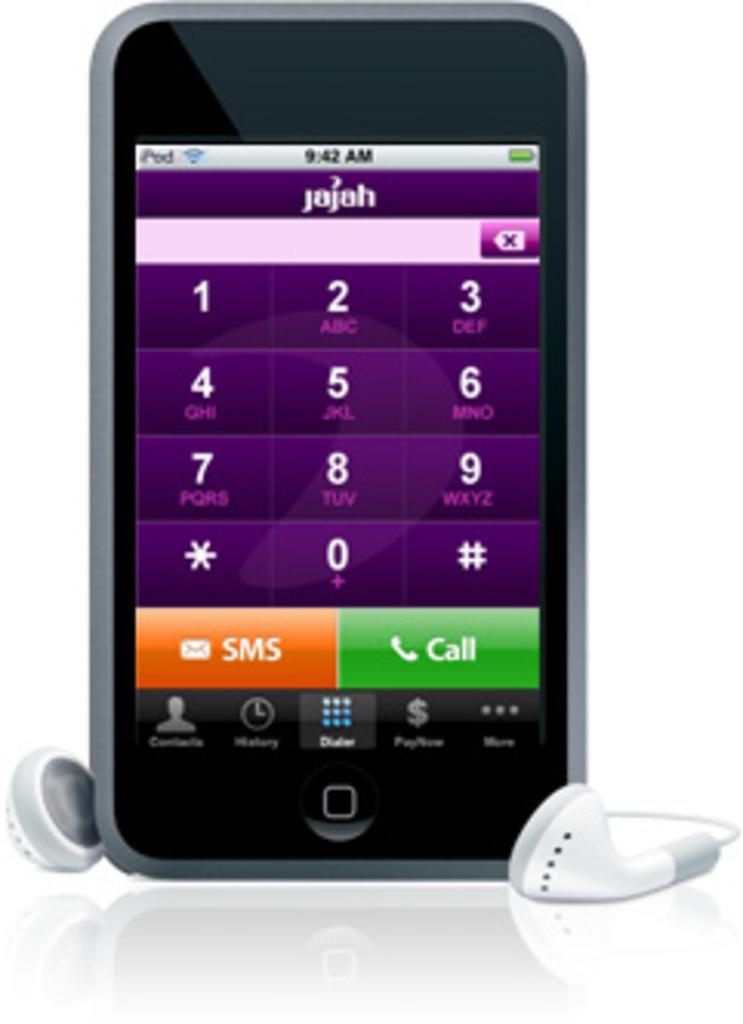Where is the call button?
Your answer should be very brief. Bottom right. What time is displayed?
Your response must be concise. 9:42 am. 